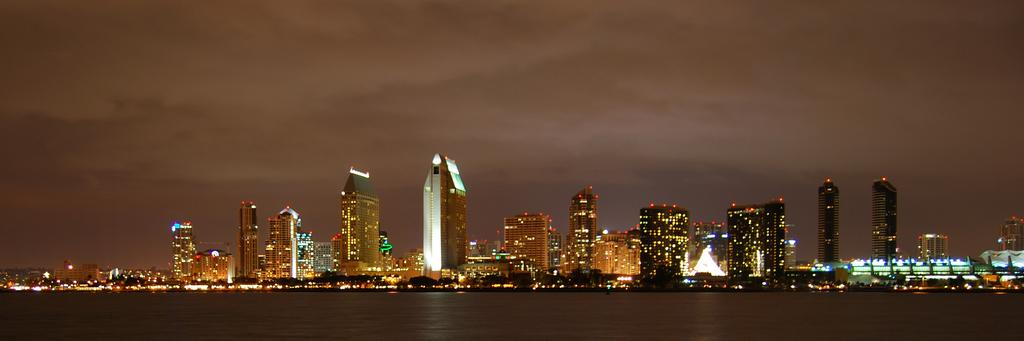What type of scene is depicted in the image? The image depicts buildings at night. What can be seen at the bottom of the image? There is water visible at the bottom of the image. What is visible at the top of the image? The sky is visible at the top of the image, and it is during nighttime. What type of meat is being prepared on the edge of the water in the image? There is no meat or any indication of food preparation in the image. 